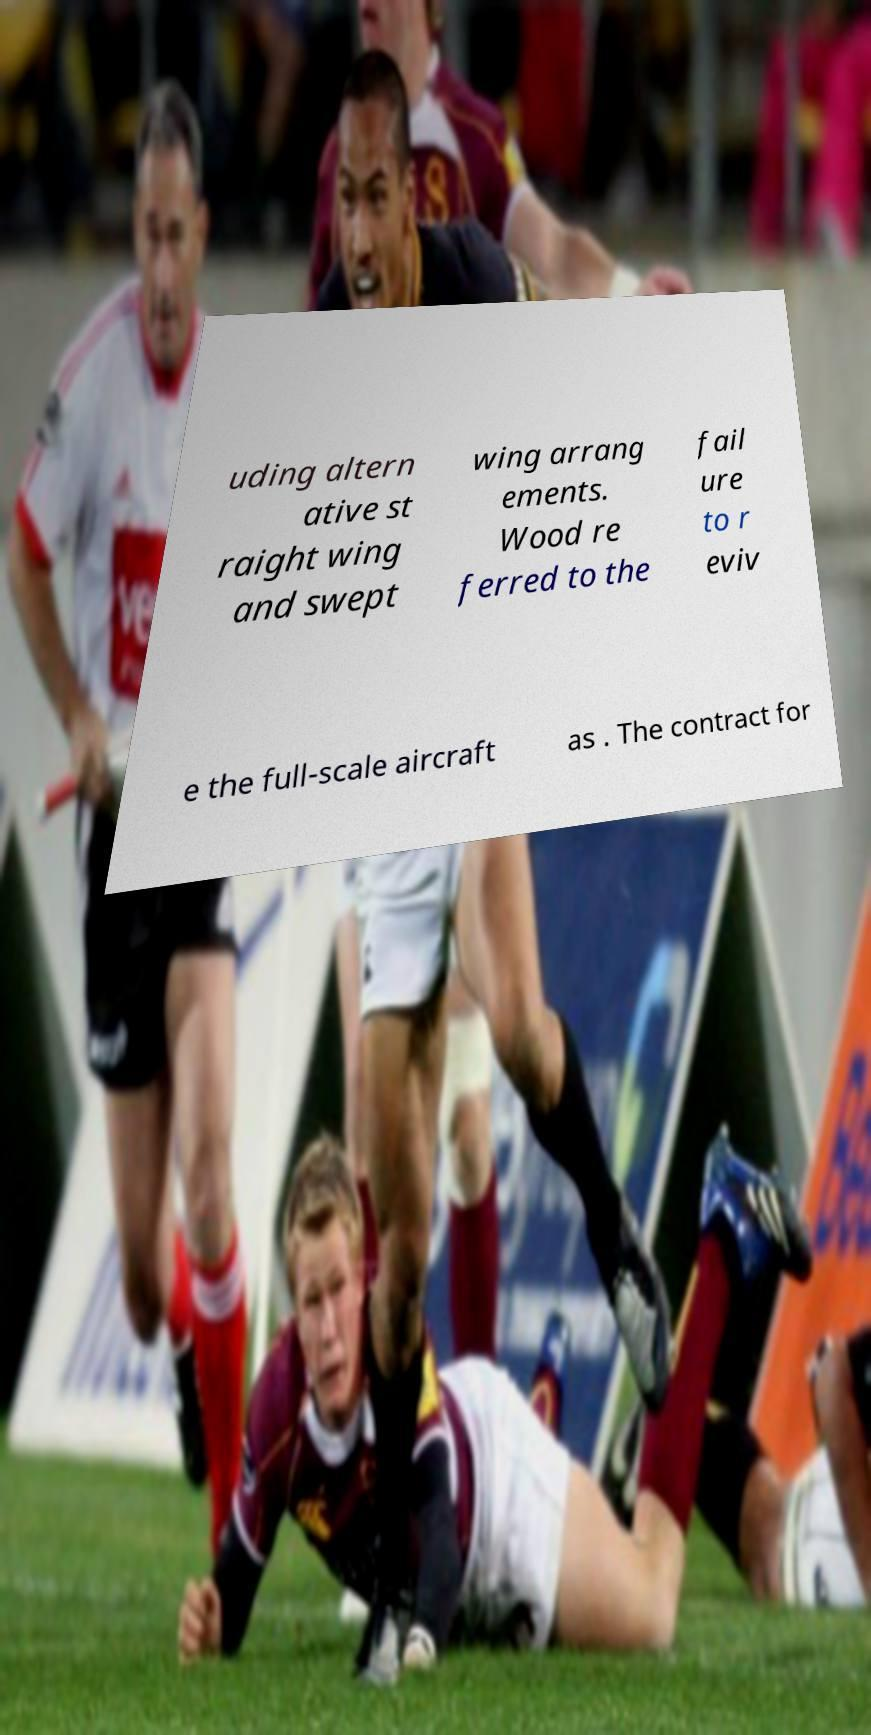Please read and relay the text visible in this image. What does it say? uding altern ative st raight wing and swept wing arrang ements. Wood re ferred to the fail ure to r eviv e the full-scale aircraft as . The contract for 